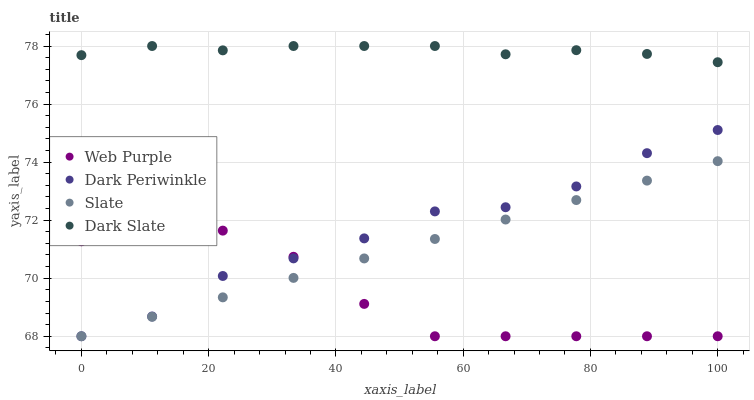Does Web Purple have the minimum area under the curve?
Answer yes or no. Yes. Does Dark Slate have the maximum area under the curve?
Answer yes or no. Yes. Does Slate have the minimum area under the curve?
Answer yes or no. No. Does Slate have the maximum area under the curve?
Answer yes or no. No. Is Slate the smoothest?
Answer yes or no. Yes. Is Dark Periwinkle the roughest?
Answer yes or no. Yes. Is Web Purple the smoothest?
Answer yes or no. No. Is Web Purple the roughest?
Answer yes or no. No. Does Web Purple have the lowest value?
Answer yes or no. Yes. Does Dark Slate have the highest value?
Answer yes or no. Yes. Does Slate have the highest value?
Answer yes or no. No. Is Web Purple less than Dark Slate?
Answer yes or no. Yes. Is Dark Slate greater than Web Purple?
Answer yes or no. Yes. Does Dark Periwinkle intersect Slate?
Answer yes or no. Yes. Is Dark Periwinkle less than Slate?
Answer yes or no. No. Is Dark Periwinkle greater than Slate?
Answer yes or no. No. Does Web Purple intersect Dark Slate?
Answer yes or no. No. 